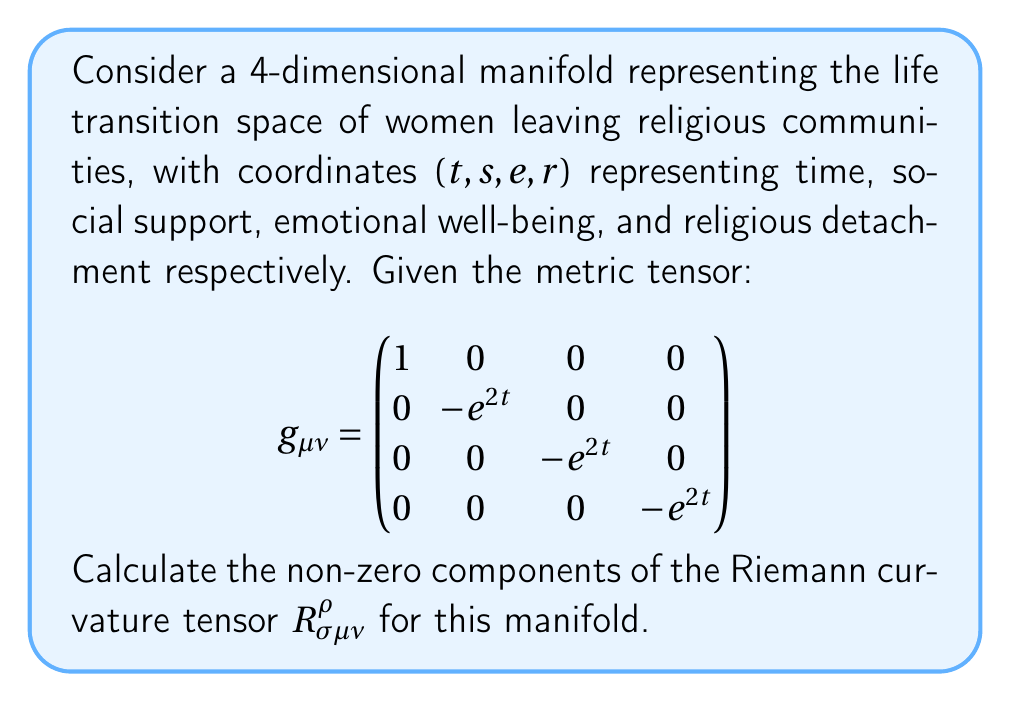Solve this math problem. To calculate the Riemann curvature tensor, we'll follow these steps:

1) First, we need to calculate the Christoffel symbols $\Gamma^{\rho}_{\mu\nu}$ using the formula:

   $$\Gamma^{\rho}_{\mu\nu} = \frac{1}{2}g^{\rho\lambda}(\partial_\mu g_{\nu\lambda} + \partial_\nu g_{\mu\lambda} - \partial_\lambda g_{\mu\nu})$$

2) The non-zero Christoffel symbols are:
   
   $$\Gamma^t_{ss} = \Gamma^t_{ee} = \Gamma^t_{rr} = e^{2t}$$
   $$\Gamma^s_{st} = \Gamma^e_{et} = \Gamma^r_{rt} = 1$$

3) Now, we can calculate the Riemann curvature tensor using:

   $$R^{\rho}_{\sigma\mu\nu} = \partial_\mu \Gamma^{\rho}_{\nu\sigma} - \partial_\nu \Gamma^{\rho}_{\mu\sigma} + \Gamma^{\rho}_{\mu\lambda}\Gamma^{\lambda}_{\nu\sigma} - \Gamma^{\rho}_{\nu\lambda}\Gamma^{\lambda}_{\mu\sigma}$$

4) The non-zero components are:

   $$R^t_{sts} = R^t_{ete} = R^t_{rtr} = e^{2t}$$
   $$R^s_{tst} = R^e_{tet} = R^r_{trt} = -1$$

5) All other components are either zero or can be derived from these through index symmetries.

This curvature tensor describes how the life transition space curves for women leaving religious communities, reflecting the interdependence of time, social support, emotional well-being, and religious detachment in this process.
Answer: $R^t_{sts} = R^t_{ete} = R^t_{rtr} = e^{2t}$, $R^s_{tst} = R^e_{tet} = R^r_{trt} = -1$ 